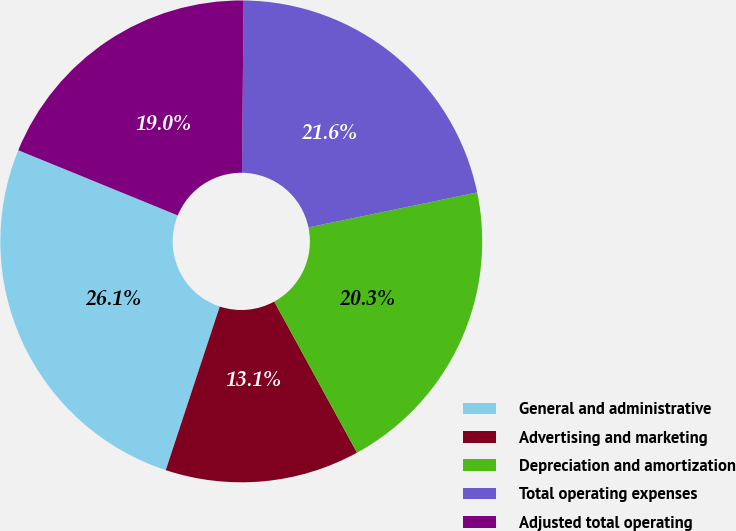<chart> <loc_0><loc_0><loc_500><loc_500><pie_chart><fcel>General and administrative<fcel>Advertising and marketing<fcel>Depreciation and amortization<fcel>Total operating expenses<fcel>Adjusted total operating<nl><fcel>26.1%<fcel>13.05%<fcel>20.28%<fcel>21.59%<fcel>18.98%<nl></chart> 